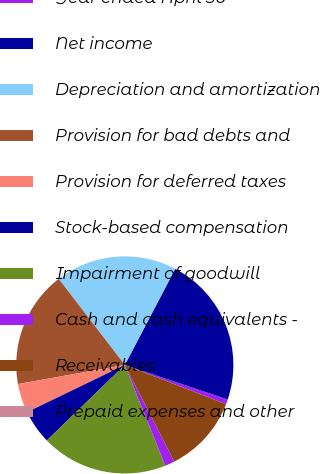Convert chart. <chart><loc_0><loc_0><loc_500><loc_500><pie_chart><fcel>Year ended April 30<fcel>Net income<fcel>Depreciation and amortization<fcel>Provision for bad debts and<fcel>Provision for deferred taxes<fcel>Stock-based compensation<fcel>Impairment of goodwill<fcel>Cash and cash equivalents -<fcel>Receivables<fcel>Prepaid expenses and other<nl><fcel>0.73%<fcel>22.46%<fcel>18.11%<fcel>17.39%<fcel>4.35%<fcel>5.07%<fcel>18.84%<fcel>1.45%<fcel>11.59%<fcel>0.0%<nl></chart> 